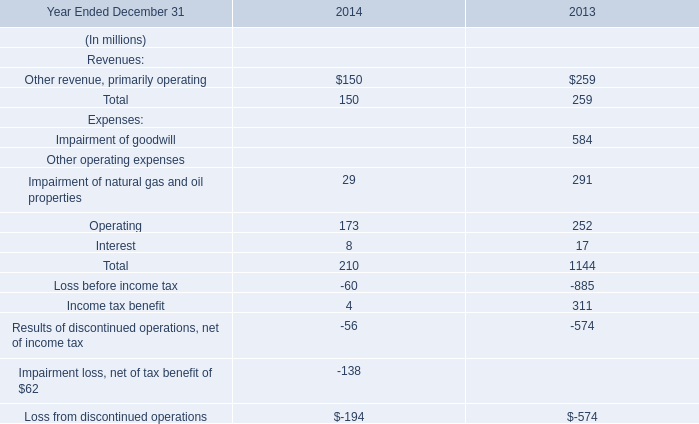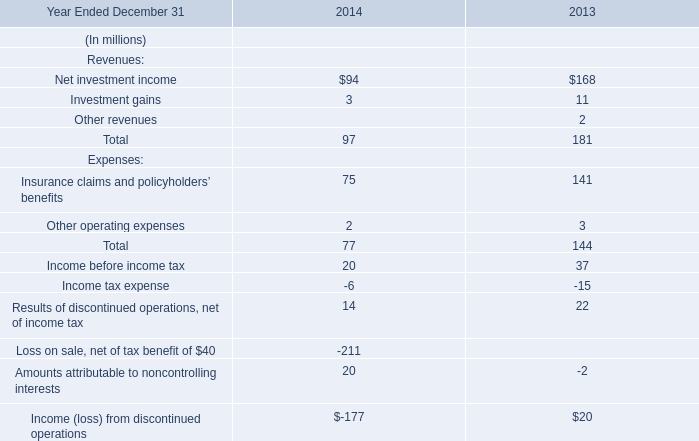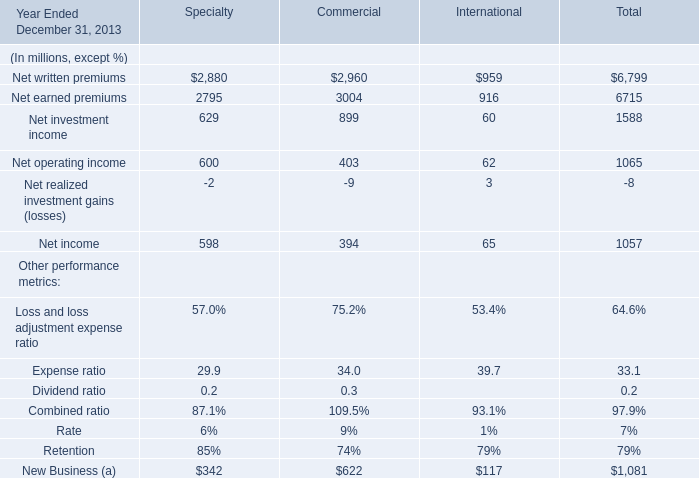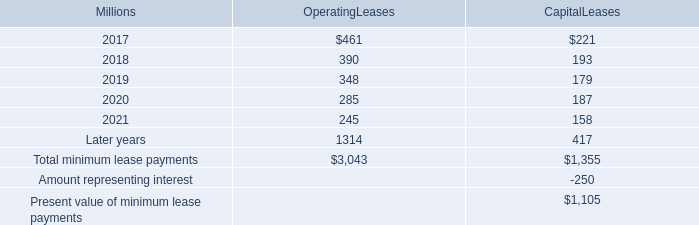Which Commercial occupies the greatest proportion in total amount in 2013? 
Computations: (3004 / (((((2960 + 3004) + 899) + 403) + 394) - 9))
Answer: 0.39263. 